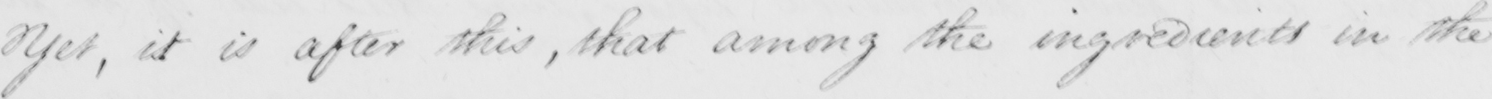Transcribe the text shown in this historical manuscript line. Yet , it is after this , that among the ingredients in the 